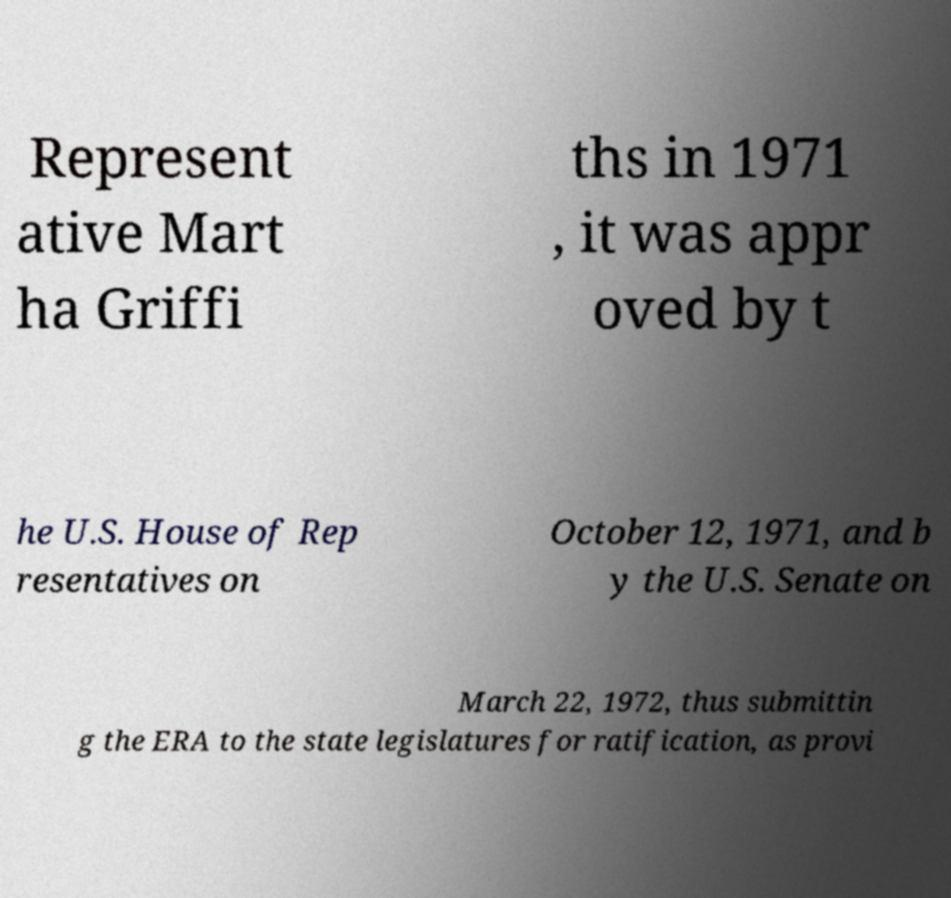Can you accurately transcribe the text from the provided image for me? Represent ative Mart ha Griffi ths in 1971 , it was appr oved by t he U.S. House of Rep resentatives on October 12, 1971, and b y the U.S. Senate on March 22, 1972, thus submittin g the ERA to the state legislatures for ratification, as provi 